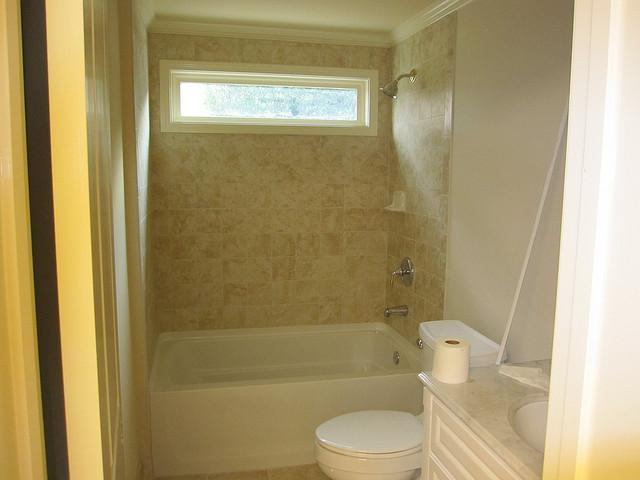How many people are wearing hat?
Give a very brief answer. 0. 